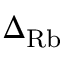<formula> <loc_0><loc_0><loc_500><loc_500>\Delta _ { R b }</formula> 